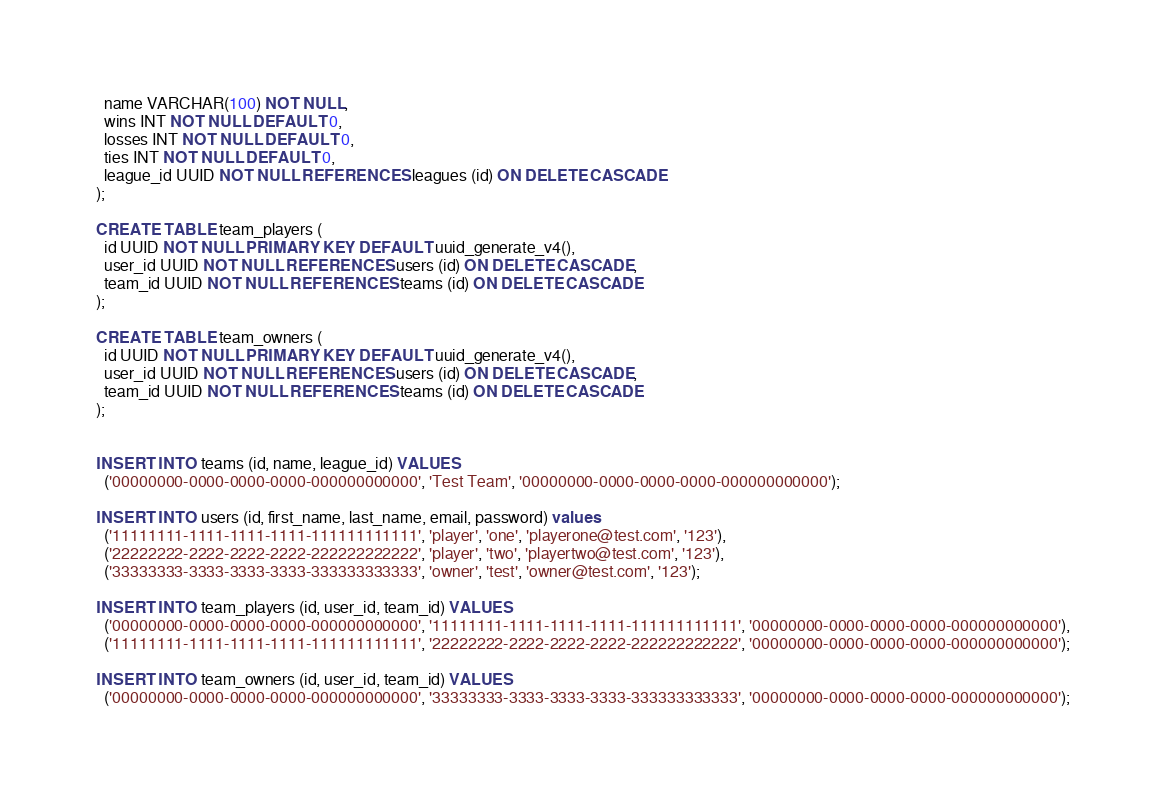Convert code to text. <code><loc_0><loc_0><loc_500><loc_500><_SQL_>  name VARCHAR(100) NOT NULL,
  wins INT NOT NULL DEFAULT 0,
  losses INT NOT NULL DEFAULT 0,
  ties INT NOT NULL DEFAULT 0,
  league_id UUID NOT NULL REFERENCES leagues (id) ON DELETE CASCADE
);

CREATE TABLE team_players (
  id UUID NOT NULL PRIMARY KEY DEFAULT uuid_generate_v4(),
  user_id UUID NOT NULL REFERENCES users (id) ON DELETE CASCADE,
  team_id UUID NOT NULL REFERENCES teams (id) ON DELETE CASCADE
);

CREATE TABLE team_owners (
  id UUID NOT NULL PRIMARY KEY DEFAULT uuid_generate_v4(),
  user_id UUID NOT NULL REFERENCES users (id) ON DELETE CASCADE,
  team_id UUID NOT NULL REFERENCES teams (id) ON DELETE CASCADE
);


INSERT INTO teams (id, name, league_id) VALUES 
  ('00000000-0000-0000-0000-000000000000', 'Test Team', '00000000-0000-0000-0000-000000000000');

INSERT INTO users (id, first_name, last_name, email, password) values 
  ('11111111-1111-1111-1111-111111111111', 'player', 'one', 'playerone@test.com', '123'),
  ('22222222-2222-2222-2222-222222222222', 'player', 'two', 'playertwo@test.com', '123'),
  ('33333333-3333-3333-3333-333333333333', 'owner', 'test', 'owner@test.com', '123');

INSERT INTO team_players (id, user_id, team_id) VALUES 
  ('00000000-0000-0000-0000-000000000000', '11111111-1111-1111-1111-111111111111', '00000000-0000-0000-0000-000000000000'),
  ('11111111-1111-1111-1111-111111111111', '22222222-2222-2222-2222-222222222222', '00000000-0000-0000-0000-000000000000');

INSERT INTO team_owners (id, user_id, team_id) VALUES
  ('00000000-0000-0000-0000-000000000000', '33333333-3333-3333-3333-333333333333', '00000000-0000-0000-0000-000000000000');</code> 